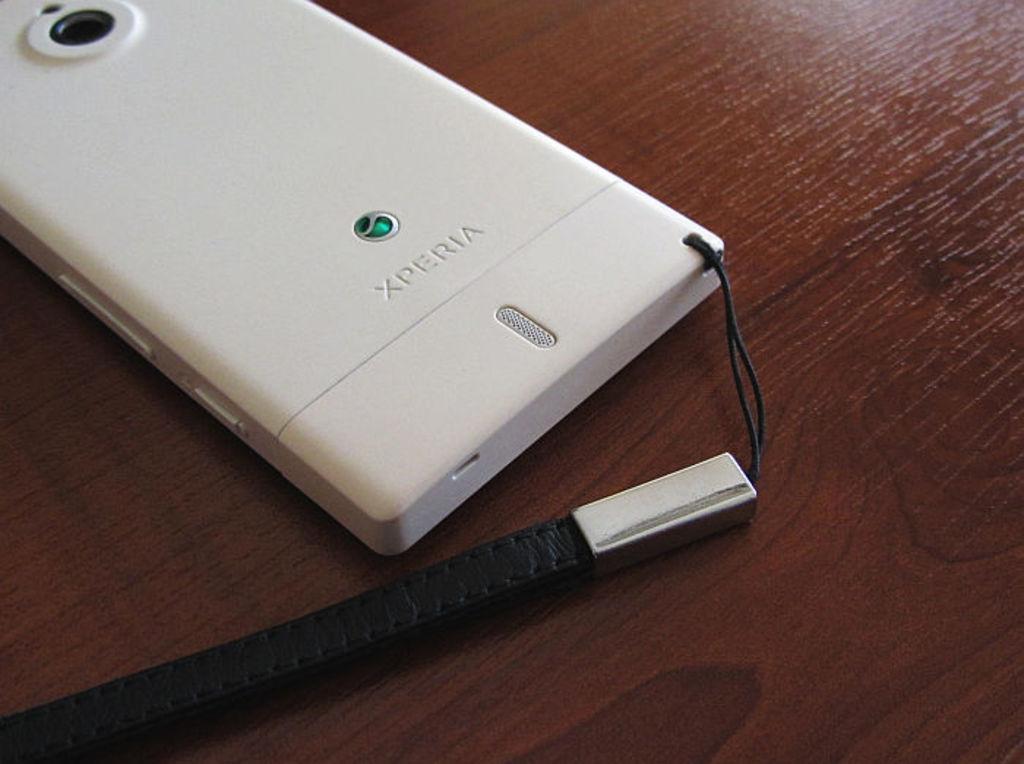Could you give a brief overview of what you see in this image? In this image we can see a mobile placed on the table. 